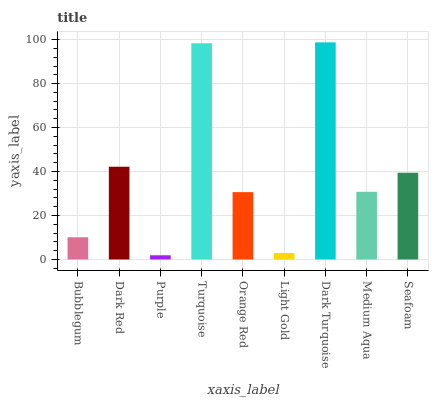Is Purple the minimum?
Answer yes or no. Yes. Is Dark Turquoise the maximum?
Answer yes or no. Yes. Is Dark Red the minimum?
Answer yes or no. No. Is Dark Red the maximum?
Answer yes or no. No. Is Dark Red greater than Bubblegum?
Answer yes or no. Yes. Is Bubblegum less than Dark Red?
Answer yes or no. Yes. Is Bubblegum greater than Dark Red?
Answer yes or no. No. Is Dark Red less than Bubblegum?
Answer yes or no. No. Is Medium Aqua the high median?
Answer yes or no. Yes. Is Medium Aqua the low median?
Answer yes or no. Yes. Is Seafoam the high median?
Answer yes or no. No. Is Bubblegum the low median?
Answer yes or no. No. 